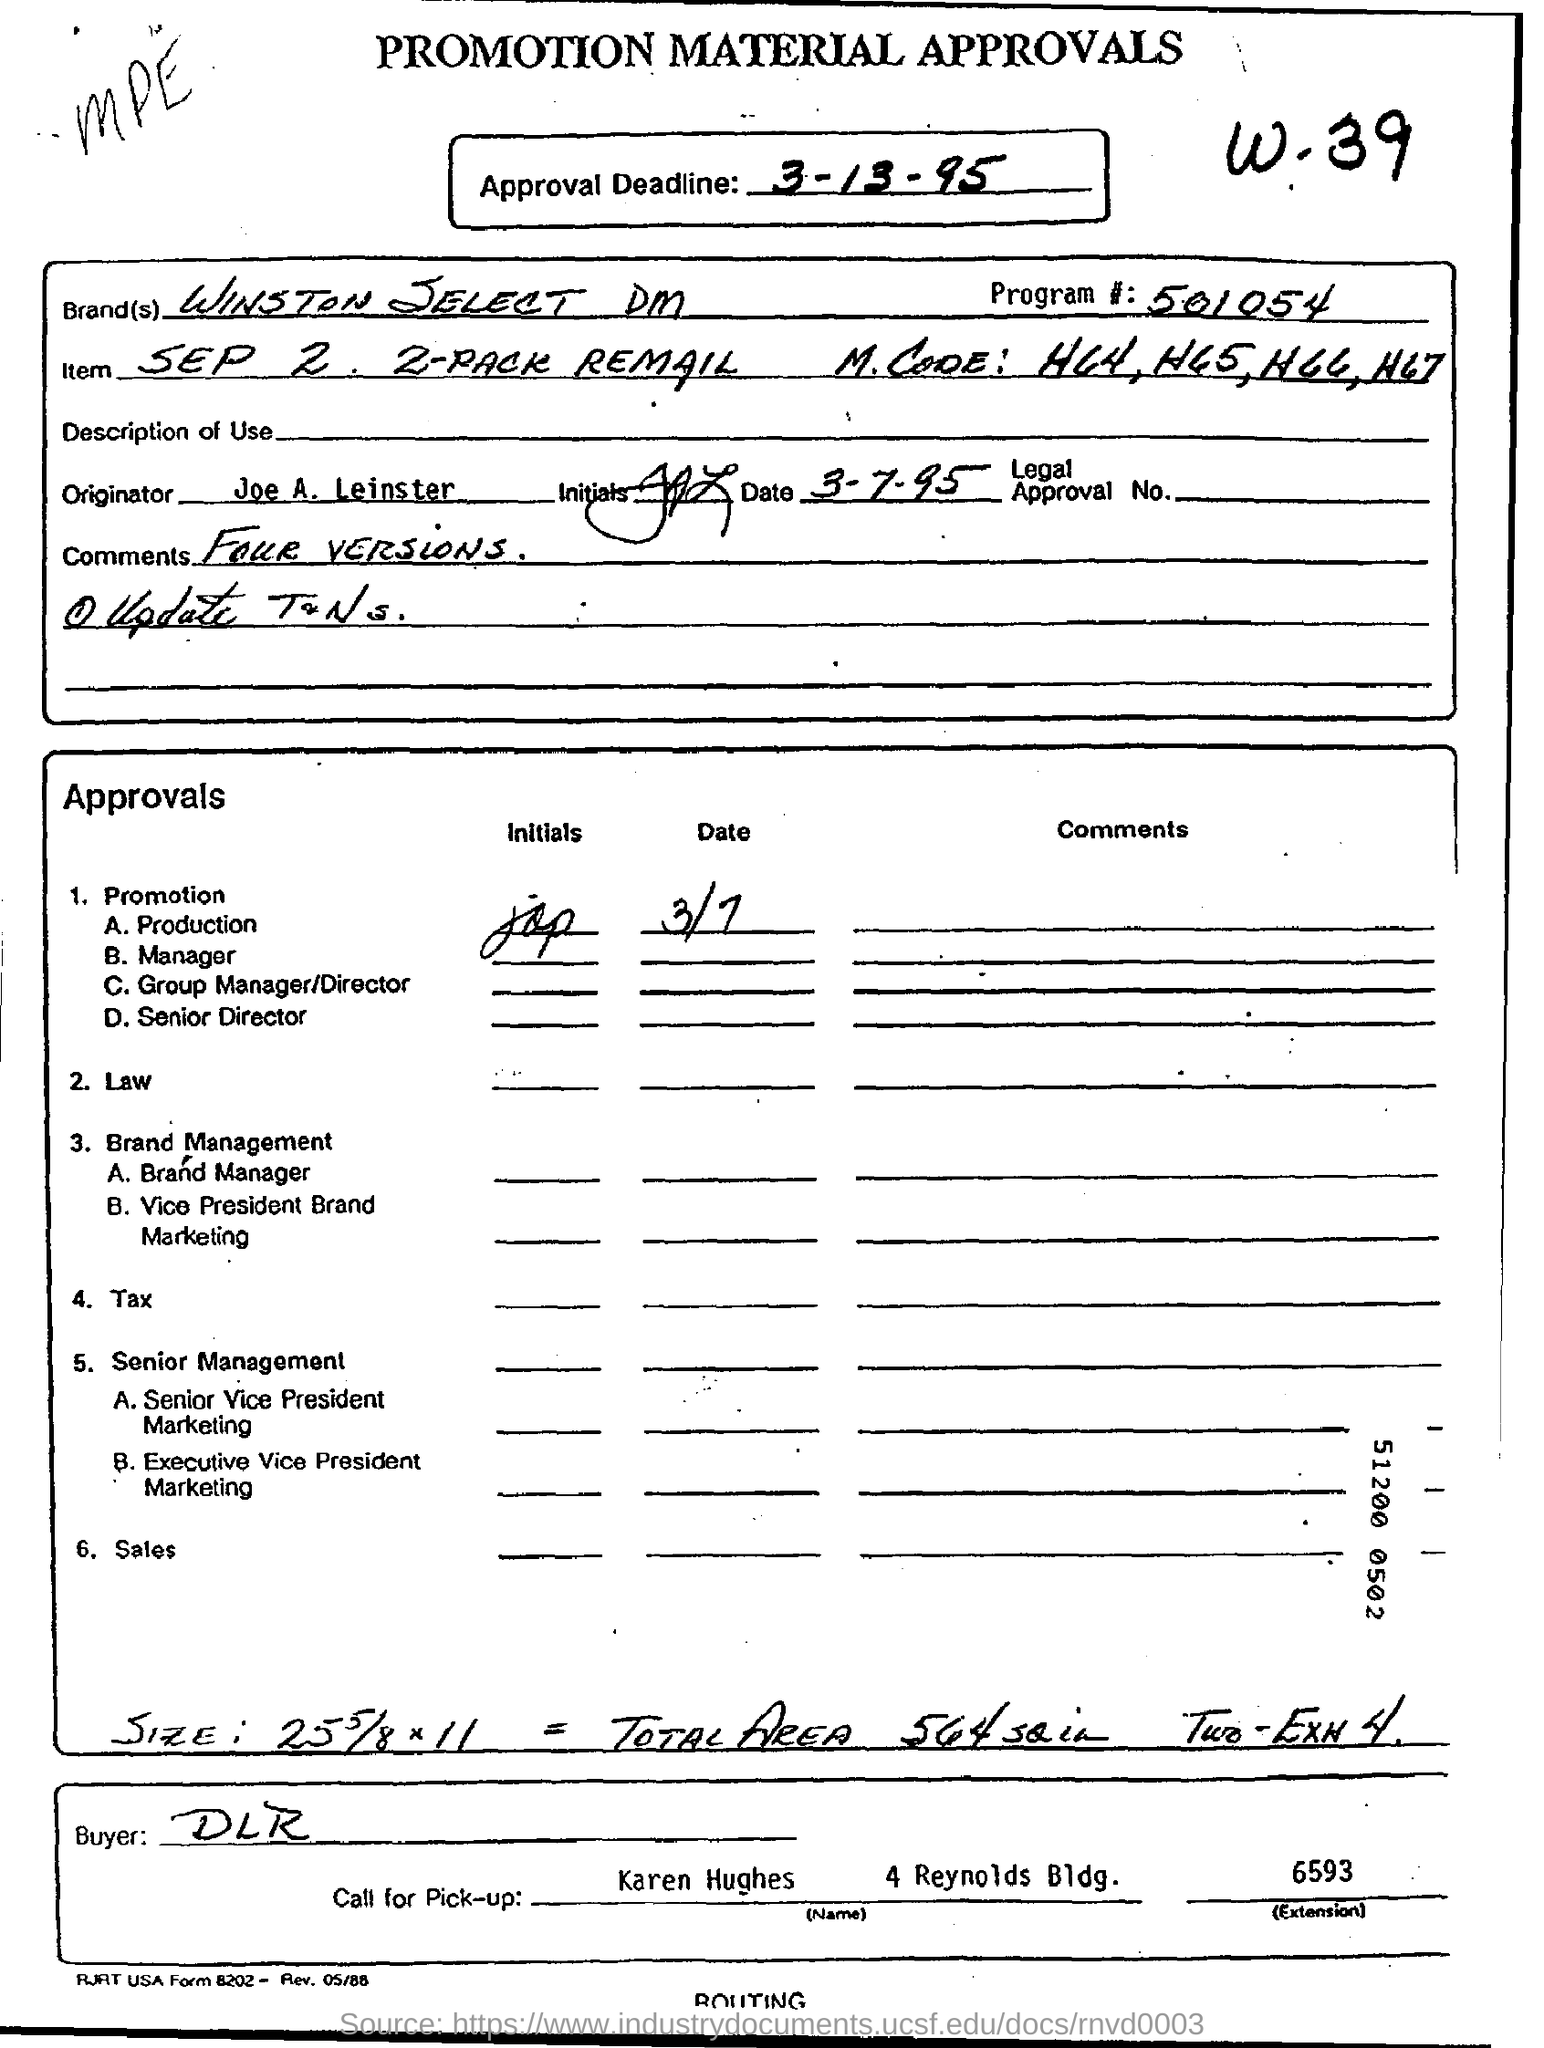Highlight a few significant elements in this photo. The main title of this paper is 'Promotion Material Approvals'. The approval deadline was March 13, 1995, as stated in the document. The last approval in the given list is for sales. The brand name is Winston Select DM. 